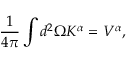<formula> <loc_0><loc_0><loc_500><loc_500>\frac { 1 } { 4 \pi } \int d ^ { 2 } \Omega K ^ { \alpha } = V ^ { \alpha } ,</formula> 